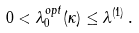Convert formula to latex. <formula><loc_0><loc_0><loc_500><loc_500>0 < \lambda _ { 0 } ^ { o p t } ( \kappa ) \leq \lambda ^ { ( 1 ) } \, .</formula> 